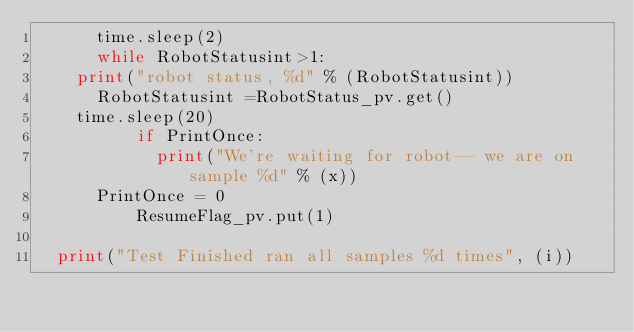<code> <loc_0><loc_0><loc_500><loc_500><_Python_>	    time.sleep(2)
	    while RobotStatusint>1: 
		print("robot status, %d" % (RobotStatusint))
	   	RobotStatusint =RobotStatus_pv.get()
		time.sleep(20)
        	if PrintOnce:
        		print("We're waiting for robot-- we are on sample %d" % (x))
			PrintOnce = 0
        	ResumeFlag_pv.put(1)

	print("Test Finished ran all samples %d times", (i))


</code> 